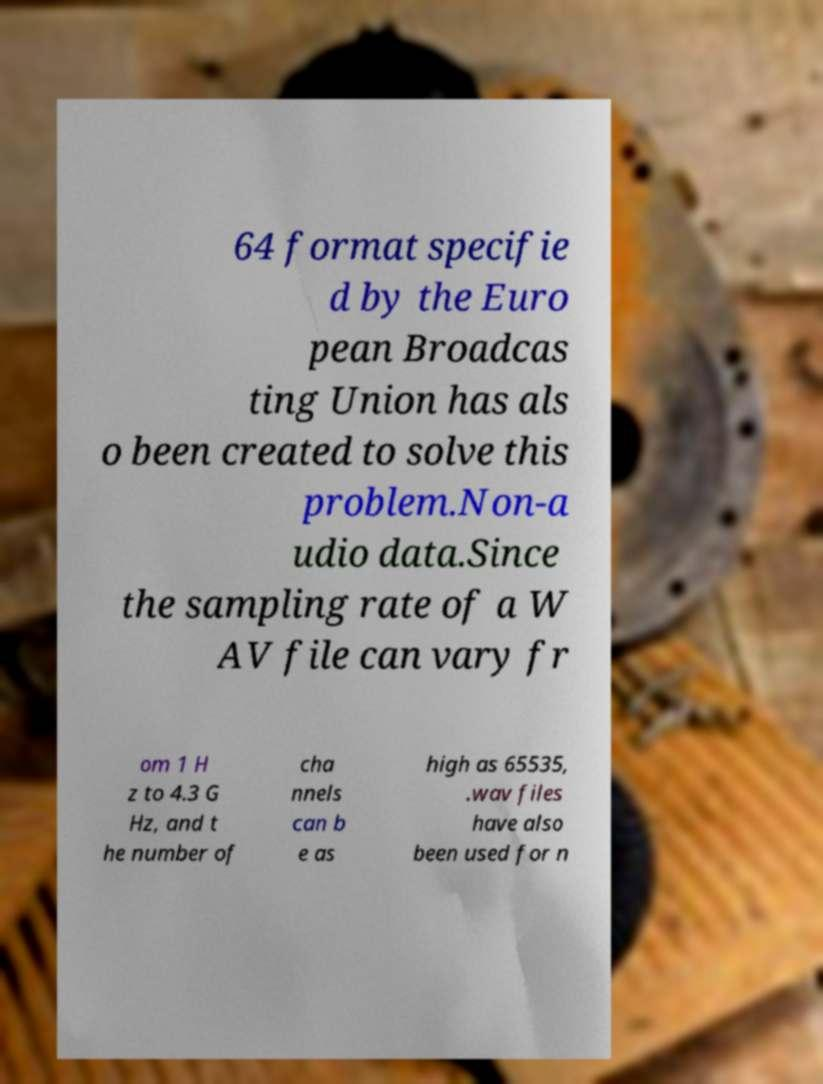Could you extract and type out the text from this image? 64 format specifie d by the Euro pean Broadcas ting Union has als o been created to solve this problem.Non-a udio data.Since the sampling rate of a W AV file can vary fr om 1 H z to 4.3 G Hz, and t he number of cha nnels can b e as high as 65535, .wav files have also been used for n 